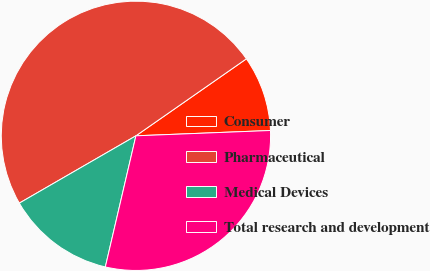Convert chart. <chart><loc_0><loc_0><loc_500><loc_500><pie_chart><fcel>Consumer<fcel>Pharmaceutical<fcel>Medical Devices<fcel>Total research and development<nl><fcel>9.06%<fcel>48.65%<fcel>13.02%<fcel>29.28%<nl></chart> 